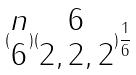Convert formula to latex. <formula><loc_0><loc_0><loc_500><loc_500>( \begin{matrix} n \\ 6 \end{matrix} ) ( \begin{matrix} 6 \\ 2 , 2 , 2 \end{matrix} ) \frac { 1 } { 6 }</formula> 